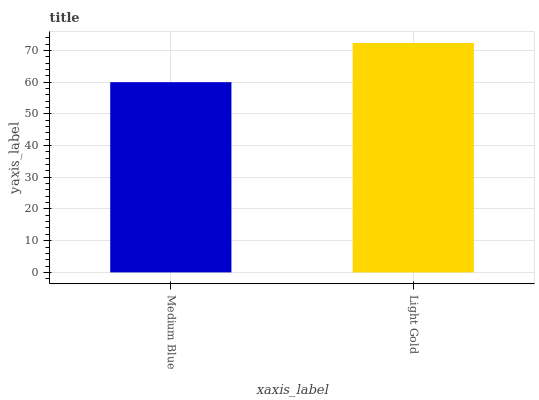Is Medium Blue the minimum?
Answer yes or no. Yes. Is Light Gold the maximum?
Answer yes or no. Yes. Is Light Gold the minimum?
Answer yes or no. No. Is Light Gold greater than Medium Blue?
Answer yes or no. Yes. Is Medium Blue less than Light Gold?
Answer yes or no. Yes. Is Medium Blue greater than Light Gold?
Answer yes or no. No. Is Light Gold less than Medium Blue?
Answer yes or no. No. Is Light Gold the high median?
Answer yes or no. Yes. Is Medium Blue the low median?
Answer yes or no. Yes. Is Medium Blue the high median?
Answer yes or no. No. Is Light Gold the low median?
Answer yes or no. No. 